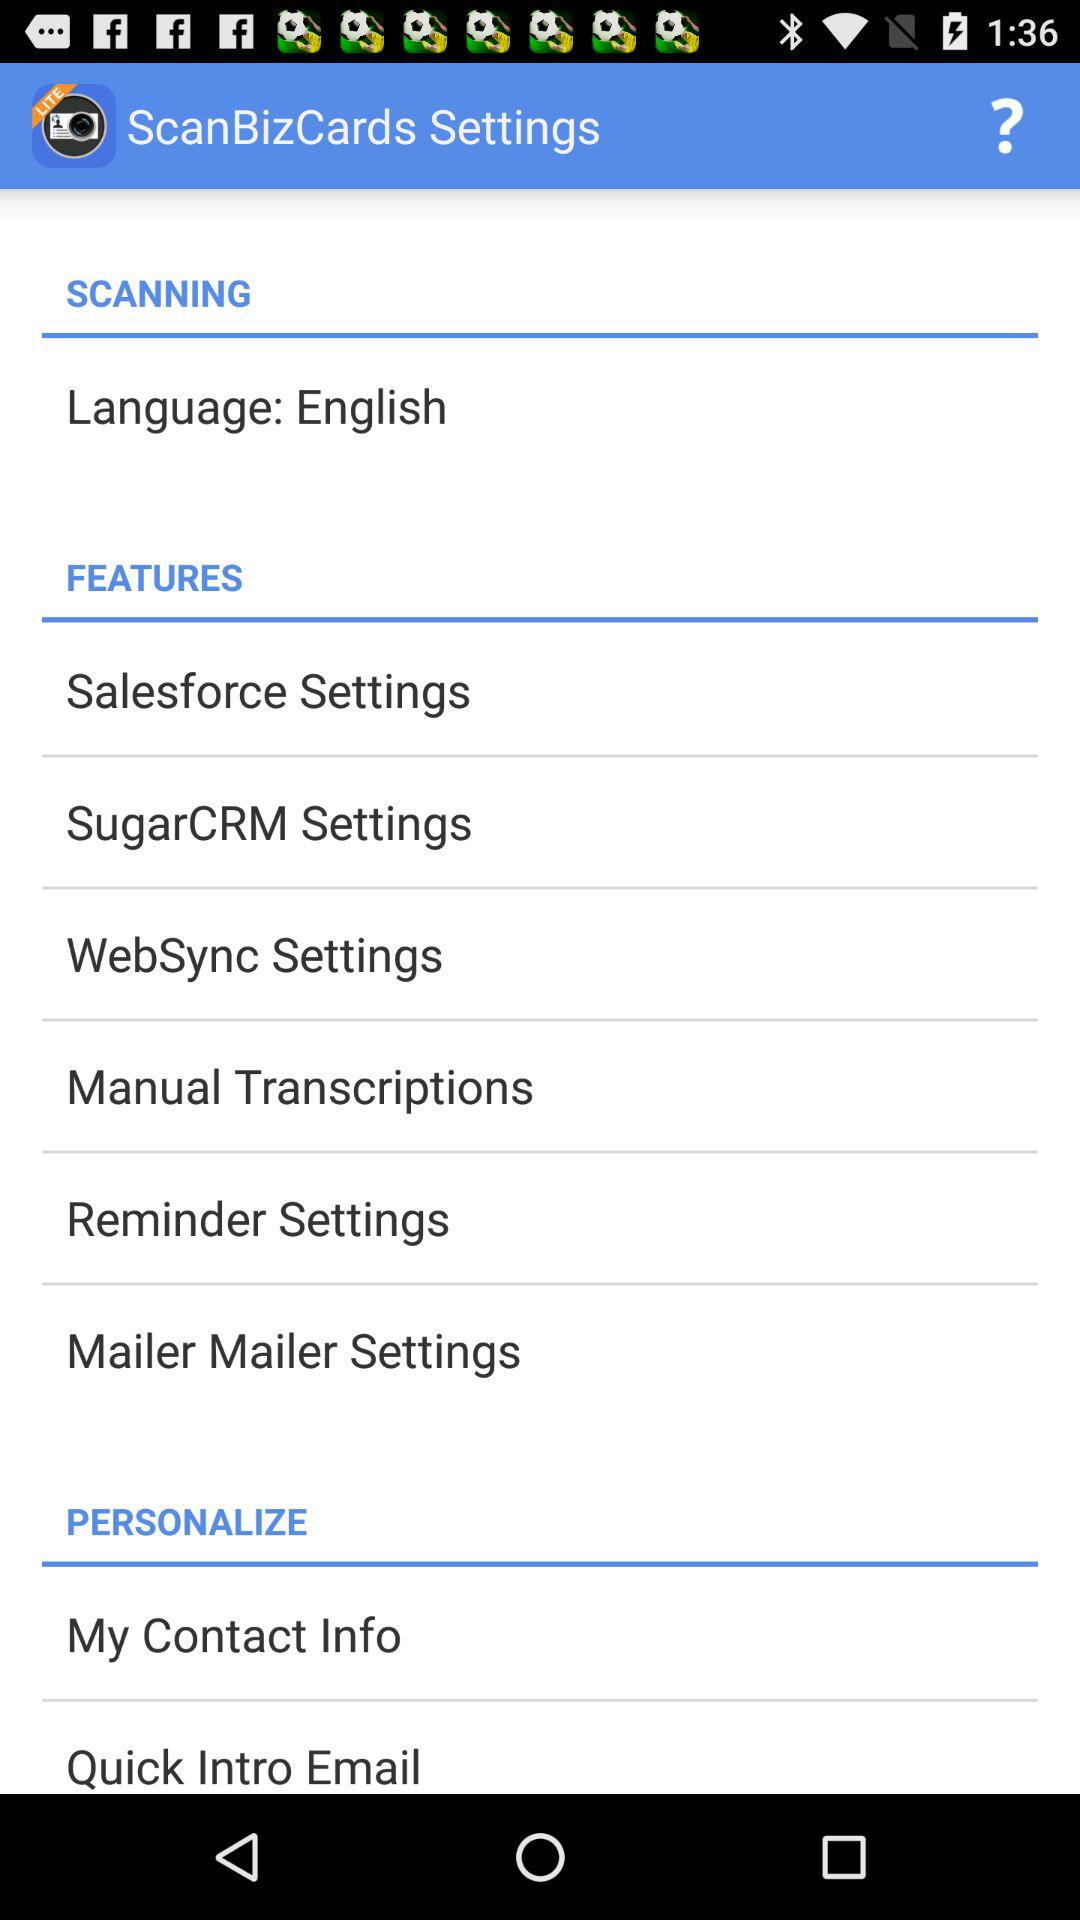Which language is set for scanning? The language set for scanning is English. 